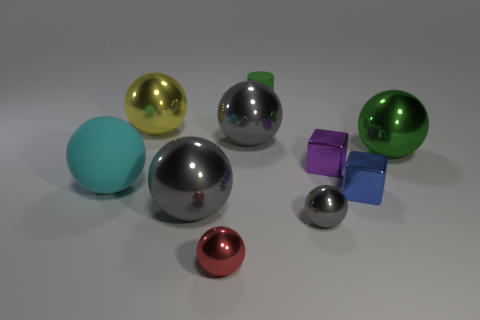Is there anything else that is made of the same material as the small red thing?
Offer a terse response. Yes. Are there any other things that are the same size as the green rubber thing?
Ensure brevity in your answer.  Yes. Do the tiny gray shiny object and the small red metallic object have the same shape?
Give a very brief answer. Yes. How many small things are either gray metallic things or blue metallic objects?
Give a very brief answer. 2. There is a small red metal object; are there any gray objects to the left of it?
Ensure brevity in your answer.  Yes. Is the number of big spheres on the right side of the green rubber object the same as the number of large cyan metallic cubes?
Offer a very short reply. No. There is a purple thing that is the same shape as the blue thing; what size is it?
Provide a short and direct response. Small. Do the yellow object and the tiny shiny thing behind the big rubber sphere have the same shape?
Provide a short and direct response. No. There is a gray metal object that is left of the gray metallic thing behind the cyan matte object; what is its size?
Your answer should be compact. Large. Are there an equal number of small shiny cubes that are in front of the tiny purple block and blue cubes that are behind the green matte cylinder?
Your answer should be very brief. No. 